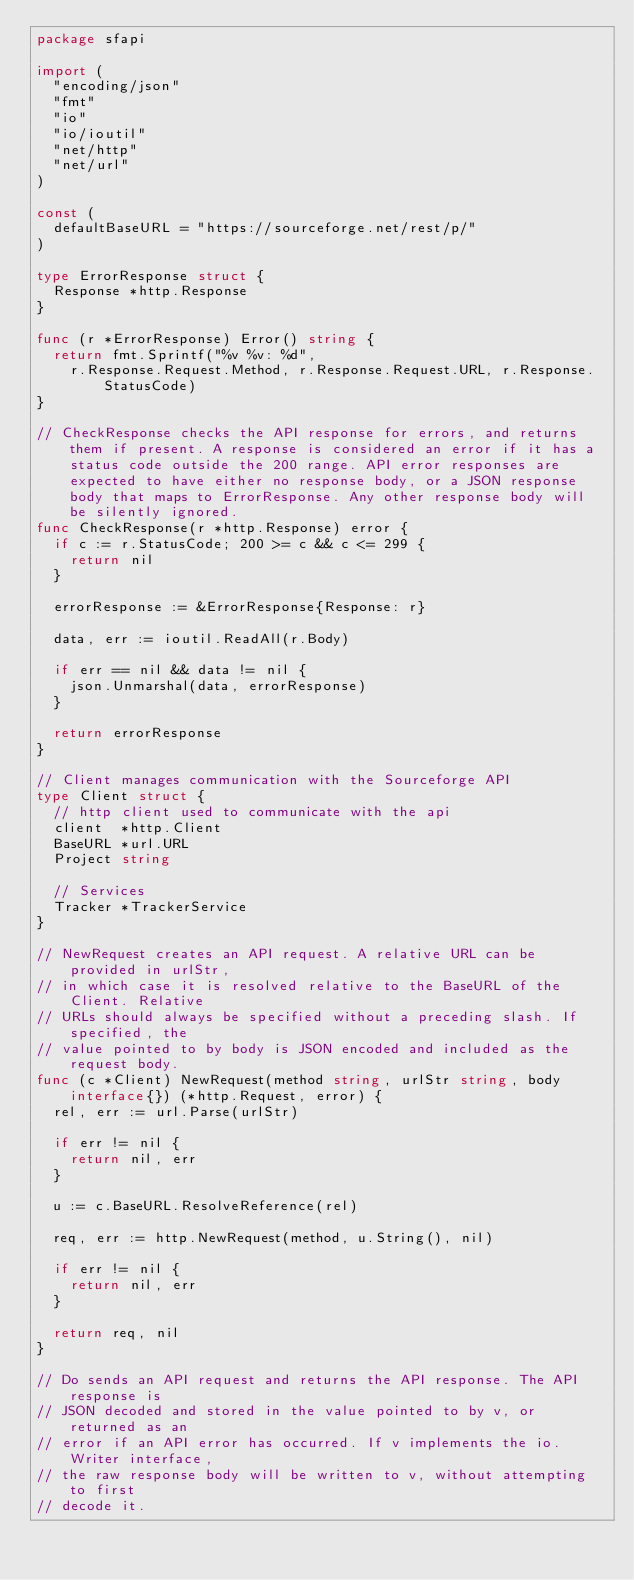Convert code to text. <code><loc_0><loc_0><loc_500><loc_500><_Go_>package sfapi

import (
	"encoding/json"
	"fmt"
	"io"
	"io/ioutil"
	"net/http"
	"net/url"
)

const (
	defaultBaseURL = "https://sourceforge.net/rest/p/"
)

type ErrorResponse struct {
	Response *http.Response
}

func (r *ErrorResponse) Error() string {
	return fmt.Sprintf("%v %v: %d",
		r.Response.Request.Method, r.Response.Request.URL, r.Response.StatusCode)
}

// CheckResponse checks the API response for errors, and returns them if present. A response is considered an error if it has a status code outside the 200 range. API error responses are expected to have either no response body, or a JSON response body that maps to ErrorResponse. Any other response body will be silently ignored.
func CheckResponse(r *http.Response) error {
	if c := r.StatusCode; 200 >= c && c <= 299 {
		return nil
	}

	errorResponse := &ErrorResponse{Response: r}

	data, err := ioutil.ReadAll(r.Body)

	if err == nil && data != nil {
		json.Unmarshal(data, errorResponse)
	}

	return errorResponse
}

// Client manages communication with the Sourceforge API
type Client struct {
	// http client used to communicate with the api
	client  *http.Client
	BaseURL *url.URL
	Project string

	// Services
	Tracker *TrackerService
}

// NewRequest creates an API request. A relative URL can be provided in urlStr,
// in which case it is resolved relative to the BaseURL of the Client. Relative
// URLs should always be specified without a preceding slash. If specified, the
// value pointed to by body is JSON encoded and included as the request body.
func (c *Client) NewRequest(method string, urlStr string, body interface{}) (*http.Request, error) {
	rel, err := url.Parse(urlStr)

	if err != nil {
		return nil, err
	}

	u := c.BaseURL.ResolveReference(rel)

	req, err := http.NewRequest(method, u.String(), nil)

	if err != nil {
		return nil, err
	}

	return req, nil
}

// Do sends an API request and returns the API response. The API response is
// JSON decoded and stored in the value pointed to by v, or returned as an
// error if an API error has occurred. If v implements the io.Writer interface,
// the raw response body will be written to v, without attempting to first
// decode it.</code> 